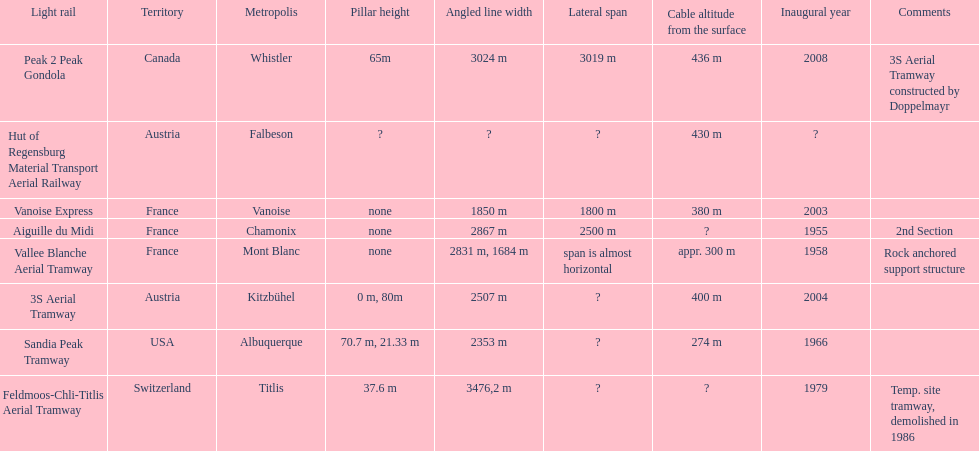How many aerial tramways are located in france? 3. 